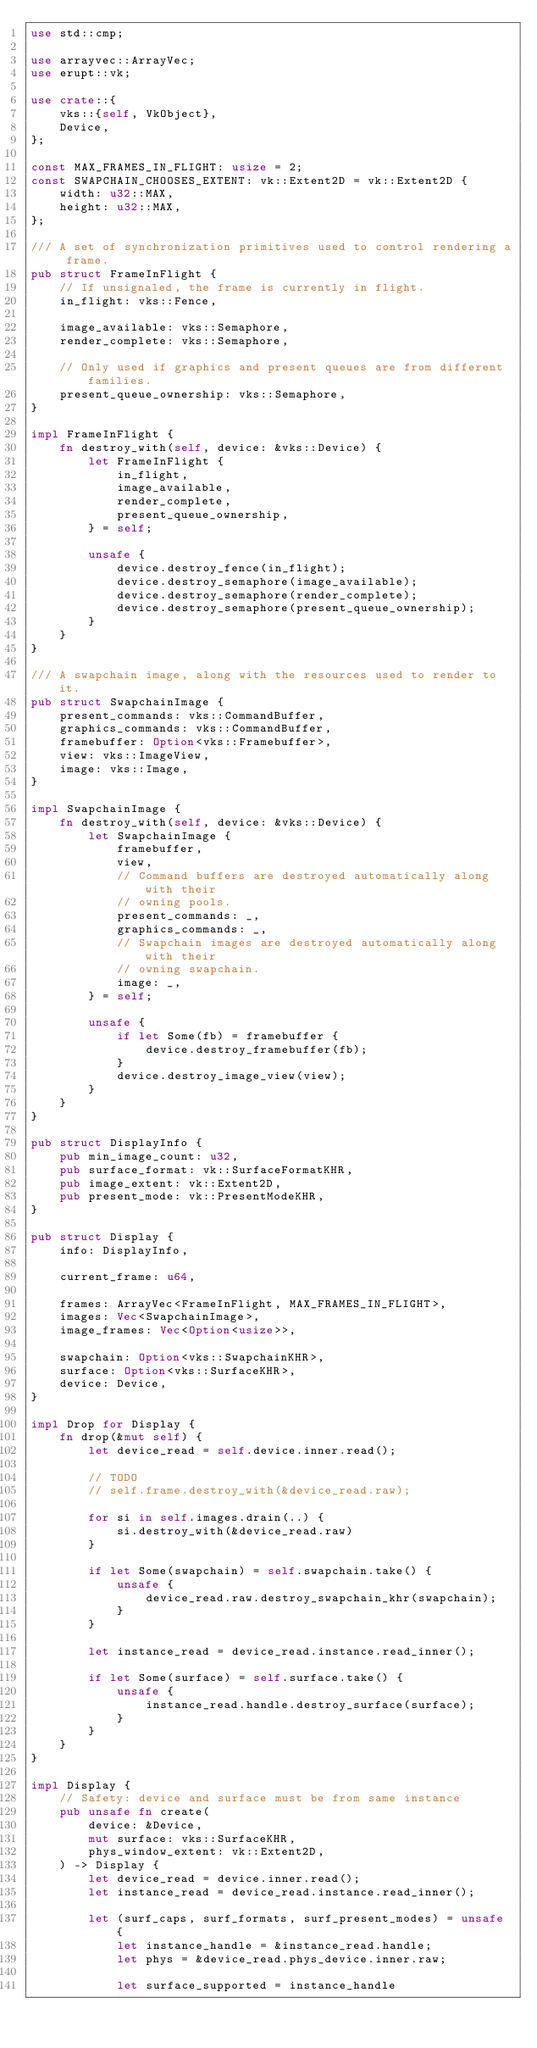Convert code to text. <code><loc_0><loc_0><loc_500><loc_500><_Rust_>use std::cmp;

use arrayvec::ArrayVec;
use erupt::vk;

use crate::{
    vks::{self, VkObject},
    Device,
};

const MAX_FRAMES_IN_FLIGHT: usize = 2;
const SWAPCHAIN_CHOOSES_EXTENT: vk::Extent2D = vk::Extent2D {
    width: u32::MAX,
    height: u32::MAX,
};

/// A set of synchronization primitives used to control rendering a frame.
pub struct FrameInFlight {
    // If unsignaled, the frame is currently in flight.
    in_flight: vks::Fence,

    image_available: vks::Semaphore,
    render_complete: vks::Semaphore,

    // Only used if graphics and present queues are from different families.
    present_queue_ownership: vks::Semaphore,
}

impl FrameInFlight {
    fn destroy_with(self, device: &vks::Device) {
        let FrameInFlight {
            in_flight,
            image_available,
            render_complete,
            present_queue_ownership,
        } = self;

        unsafe {
            device.destroy_fence(in_flight);
            device.destroy_semaphore(image_available);
            device.destroy_semaphore(render_complete);
            device.destroy_semaphore(present_queue_ownership);
        }
    }
}

/// A swapchain image, along with the resources used to render to it.
pub struct SwapchainImage {
    present_commands: vks::CommandBuffer,
    graphics_commands: vks::CommandBuffer,
    framebuffer: Option<vks::Framebuffer>,
    view: vks::ImageView,
    image: vks::Image,
}

impl SwapchainImage {
    fn destroy_with(self, device: &vks::Device) {
        let SwapchainImage {
            framebuffer,
            view,
            // Command buffers are destroyed automatically along with their
            // owning pools.
            present_commands: _,
            graphics_commands: _,
            // Swapchain images are destroyed automatically along with their
            // owning swapchain.
            image: _,
        } = self;

        unsafe {
            if let Some(fb) = framebuffer {
                device.destroy_framebuffer(fb);
            }
            device.destroy_image_view(view);
        }
    }
}

pub struct DisplayInfo {
    pub min_image_count: u32,
    pub surface_format: vk::SurfaceFormatKHR,
    pub image_extent: vk::Extent2D,
    pub present_mode: vk::PresentModeKHR,
}

pub struct Display {
    info: DisplayInfo,

    current_frame: u64,

    frames: ArrayVec<FrameInFlight, MAX_FRAMES_IN_FLIGHT>,
    images: Vec<SwapchainImage>,
    image_frames: Vec<Option<usize>>,

    swapchain: Option<vks::SwapchainKHR>,
    surface: Option<vks::SurfaceKHR>,
    device: Device,
}

impl Drop for Display {
    fn drop(&mut self) {
        let device_read = self.device.inner.read();

        // TODO
        // self.frame.destroy_with(&device_read.raw);

        for si in self.images.drain(..) {
            si.destroy_with(&device_read.raw)
        }

        if let Some(swapchain) = self.swapchain.take() {
            unsafe {
                device_read.raw.destroy_swapchain_khr(swapchain);
            }
        }

        let instance_read = device_read.instance.read_inner();

        if let Some(surface) = self.surface.take() {
            unsafe {
                instance_read.handle.destroy_surface(surface);
            }
        }
    }
}

impl Display {
    // Safety: device and surface must be from same instance
    pub unsafe fn create(
        device: &Device,
        mut surface: vks::SurfaceKHR,
        phys_window_extent: vk::Extent2D,
    ) -> Display {
        let device_read = device.inner.read();
        let instance_read = device_read.instance.read_inner();

        let (surf_caps, surf_formats, surf_present_modes) = unsafe {
            let instance_handle = &instance_read.handle;
            let phys = &device_read.phys_device.inner.raw;

            let surface_supported = instance_handle</code> 